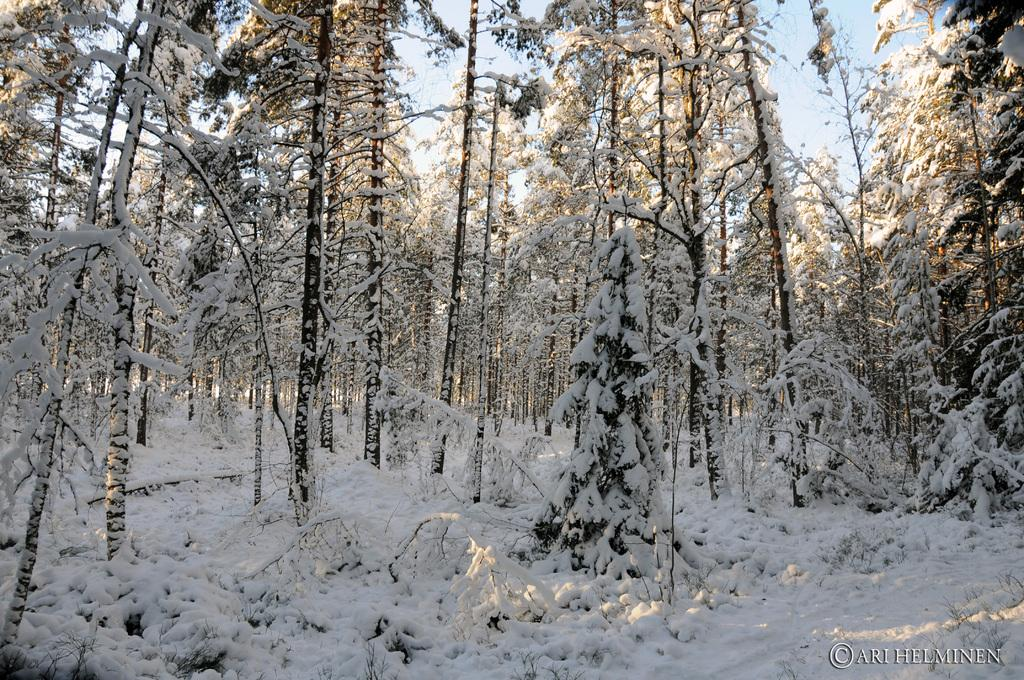What type of vegetation is present in the image? There are trees in the image. What is covering the trees in the image? The trees are covered with snow. What is covering the ground in the image? There is snow on the ground. What is visible at the top of the image? The sky is visible at the top of the image. Where is the door located in the image? There is no door present in the image; it features trees covered with snow and snow on the ground. What type of ball can be seen bouncing in the image? There is no ball present in the image. 